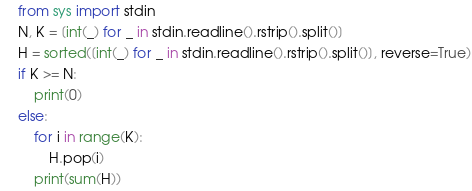<code> <loc_0><loc_0><loc_500><loc_500><_Python_>from sys import stdin
N, K = [int(_) for _ in stdin.readline().rstrip().split()]
H = sorted([int(_) for _ in stdin.readline().rstrip().split()], reverse=True)
if K >= N:
    print(0)
else:
    for i in range(K):
        H.pop(i)
    print(sum(H))</code> 